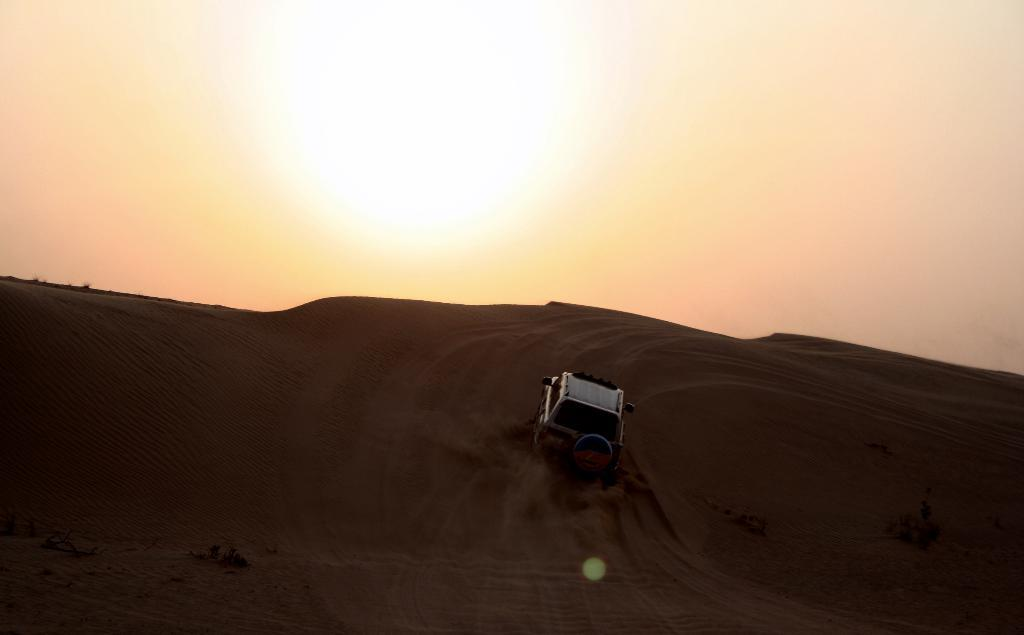What is the main subject of the image? There is a vehicle in the image. What type of terrain can be seen in the image? There is sand visible in the image. What is visible in the background of the image? The sky is visible in the image. What type of vegetation is present in the image? There is a plant in the image. What celestial body can be seen in the sky? The sun is observable in the image. What type of pot is being used for war in the image? There is no pot or any indication of war in the image. 